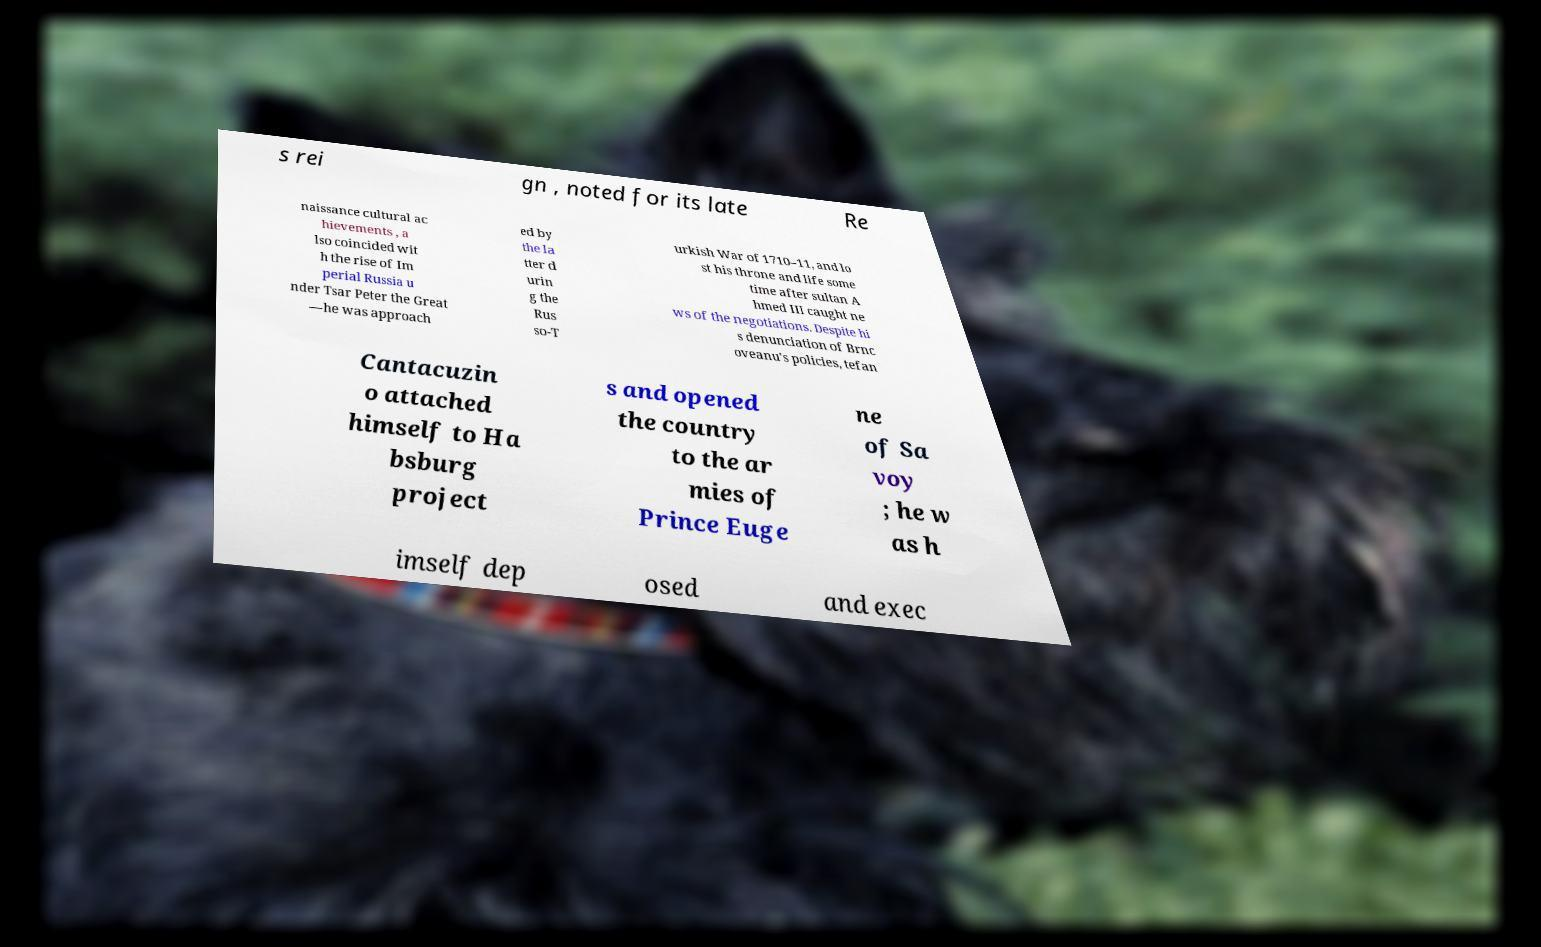Can you accurately transcribe the text from the provided image for me? s rei gn , noted for its late Re naissance cultural ac hievements , a lso coincided wit h the rise of Im perial Russia u nder Tsar Peter the Great —he was approach ed by the la tter d urin g the Rus so-T urkish War of 1710–11, and lo st his throne and life some time after sultan A hmed III caught ne ws of the negotiations. Despite hi s denunciation of Brnc oveanu's policies, tefan Cantacuzin o attached himself to Ha bsburg project s and opened the country to the ar mies of Prince Euge ne of Sa voy ; he w as h imself dep osed and exec 